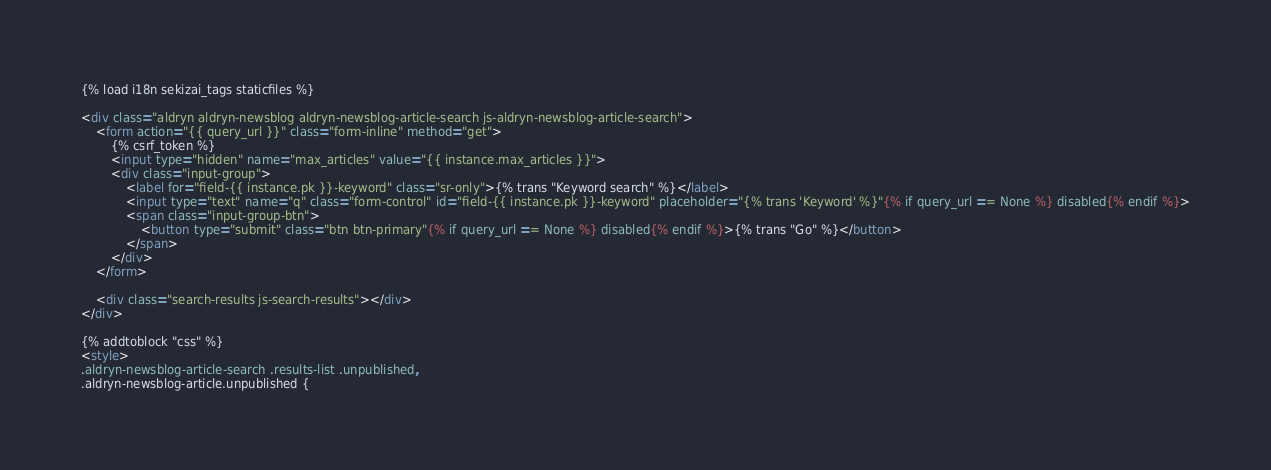Convert code to text. <code><loc_0><loc_0><loc_500><loc_500><_HTML_>{% load i18n sekizai_tags staticfiles %}

<div class="aldryn aldryn-newsblog aldryn-newsblog-article-search js-aldryn-newsblog-article-search">
    <form action="{{ query_url }}" class="form-inline" method="get">
        {% csrf_token %}
        <input type="hidden" name="max_articles" value="{{ instance.max_articles }}">
        <div class="input-group">
            <label for="field-{{ instance.pk }}-keyword" class="sr-only">{% trans "Keyword search" %}</label>
            <input type="text" name="q" class="form-control" id="field-{{ instance.pk }}-keyword" placeholder="{% trans 'Keyword' %}"{% if query_url == None %} disabled{% endif %}>
            <span class="input-group-btn">
                <button type="submit" class="btn btn-primary"{% if query_url == None %} disabled{% endif %}>{% trans "Go" %}</button>
            </span>
        </div>
    </form>

    <div class="search-results js-search-results"></div>
</div>

{% addtoblock "css" %}
<style>
.aldryn-newsblog-article-search .results-list .unpublished,
.aldryn-newsblog-article.unpublished {</code> 